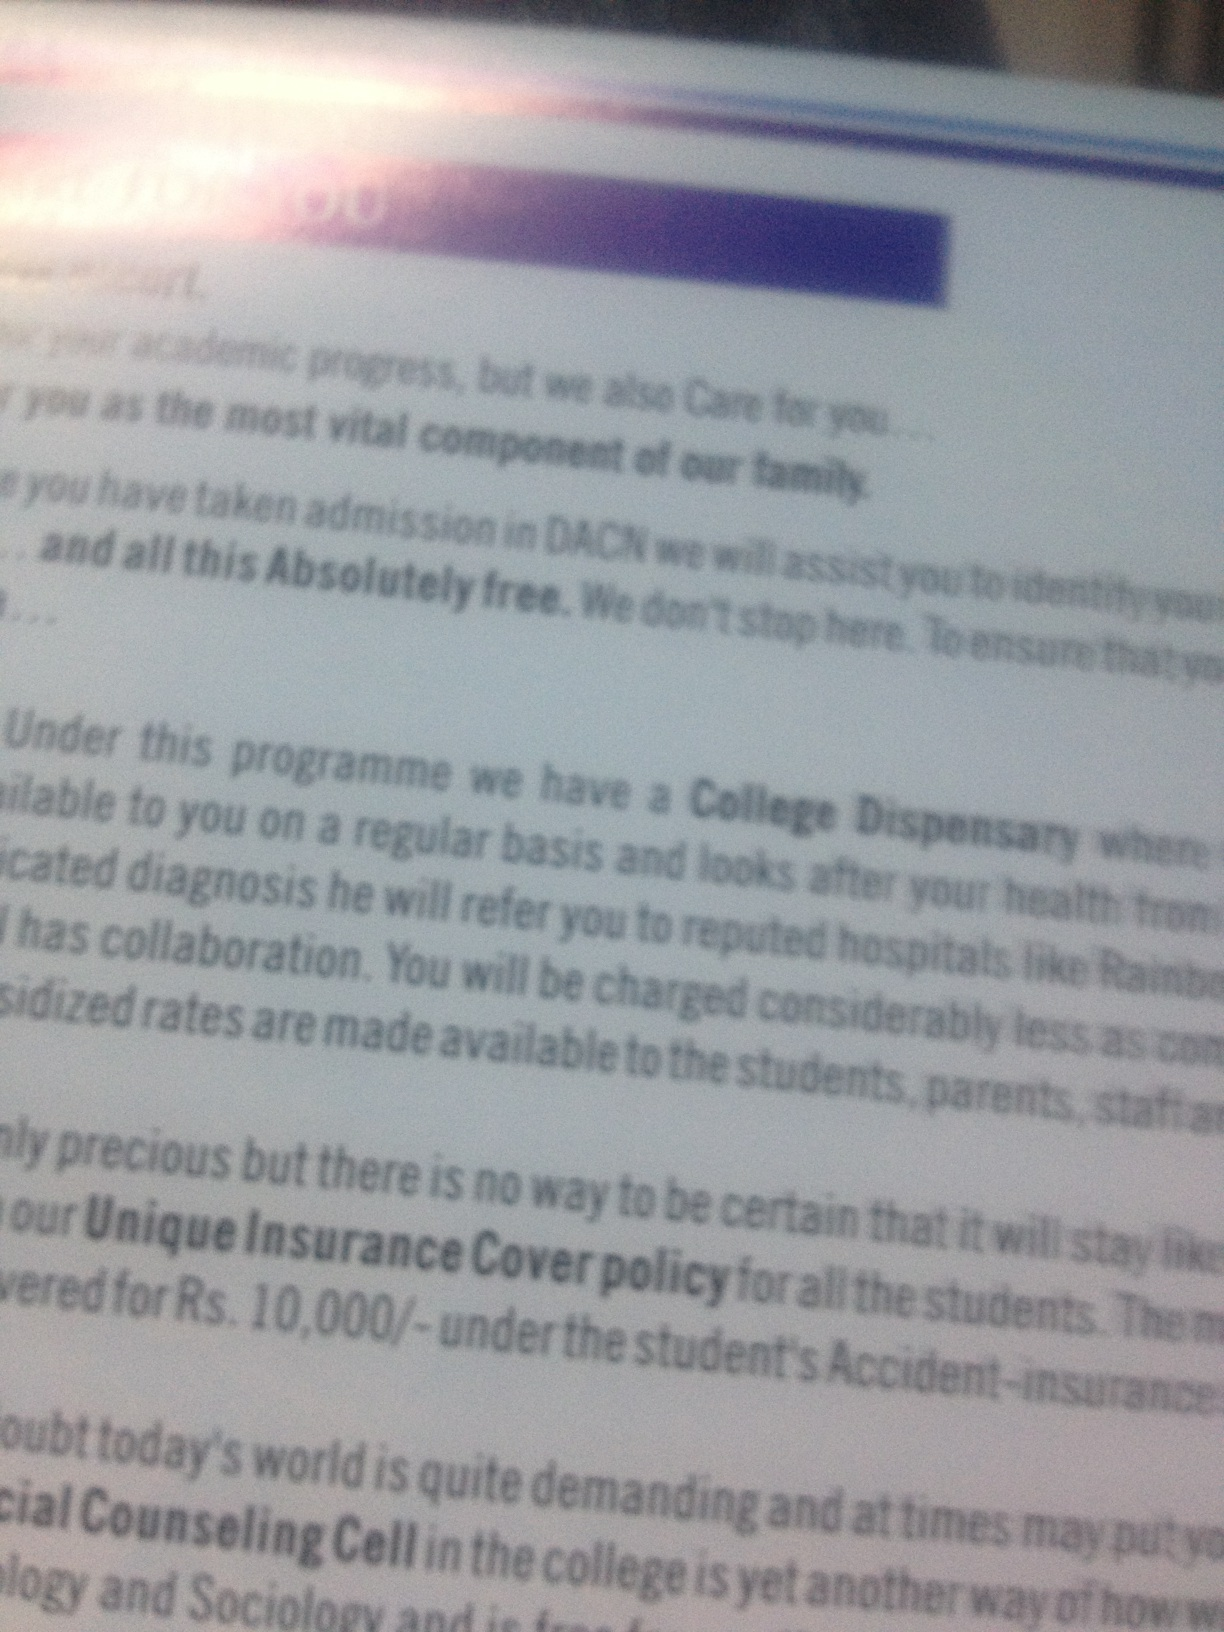Identify the primary theme in the provided text. The primary theme of the provided text seems to be student welfare and support services. It emphasizes the institution's commitment to ensuring students' health and wellbeing through various services, such as a College Dispensary, insurance cover, and counseling services. What might be the impact of these services on students' academic performance? The impact of these services on students' academic performance could be quite significant. Access to healthcare and insurance reduces anxiety related to health issues and financial stress, allowing students to focus better on their studies. Counseling services can provide support for mental health, helping students manage stress, anxiety, and other challenges more effectively. Overall, such comprehensive support systems can create a healthier, more stable environment conducive to academic success. Describe a realistic scenario where a student benefits from the College Dispensary. A realistic scenario could involve a student who starts feeling symptoms of the flu. They visit the College Dispensary, where they are quickly attended to by the medical staff. The dispensary provides immediate treatment, including medication and advice for home care, preventing the illness from worsening and spreading. The student can recuperate quicker and return to their studies without lengthy interruptions or significant stress. Describe a brief realistic scenario where a student utilizes the insurance cover policy. A student is involved in a minor accident while playing sports on campus. They need immediate medical attention and are referred to a reputed local hospital. Thanks to the insurance cover policy, the medical expenses up to Rs. 10,000/- are covered, alleviating financial worries for the student and their family. What creative ideas could further enhance student support services? Adding a virtual reality (VR) relaxation room could be an innovative enhancement. This room would simulate calming environments like beaches or forests, helping students unwind and reduce stress. Incorporating a nutrition and wellness coach to provide personalized health plans and cooking workshops would promote healthier lifestyles. Another idea could be a mentoring program pairing students with professionals in their field of study for guidance and career advice. Organizing regular mental health workshops and seminars with influential speakers could also provide ongoing support and inspiration. 